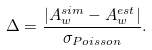Convert formula to latex. <formula><loc_0><loc_0><loc_500><loc_500>\Delta = \frac { | A ^ { s i m } _ { w } - A ^ { e s t } _ { w } | } { \sigma _ { P o i s s o n } } .</formula> 